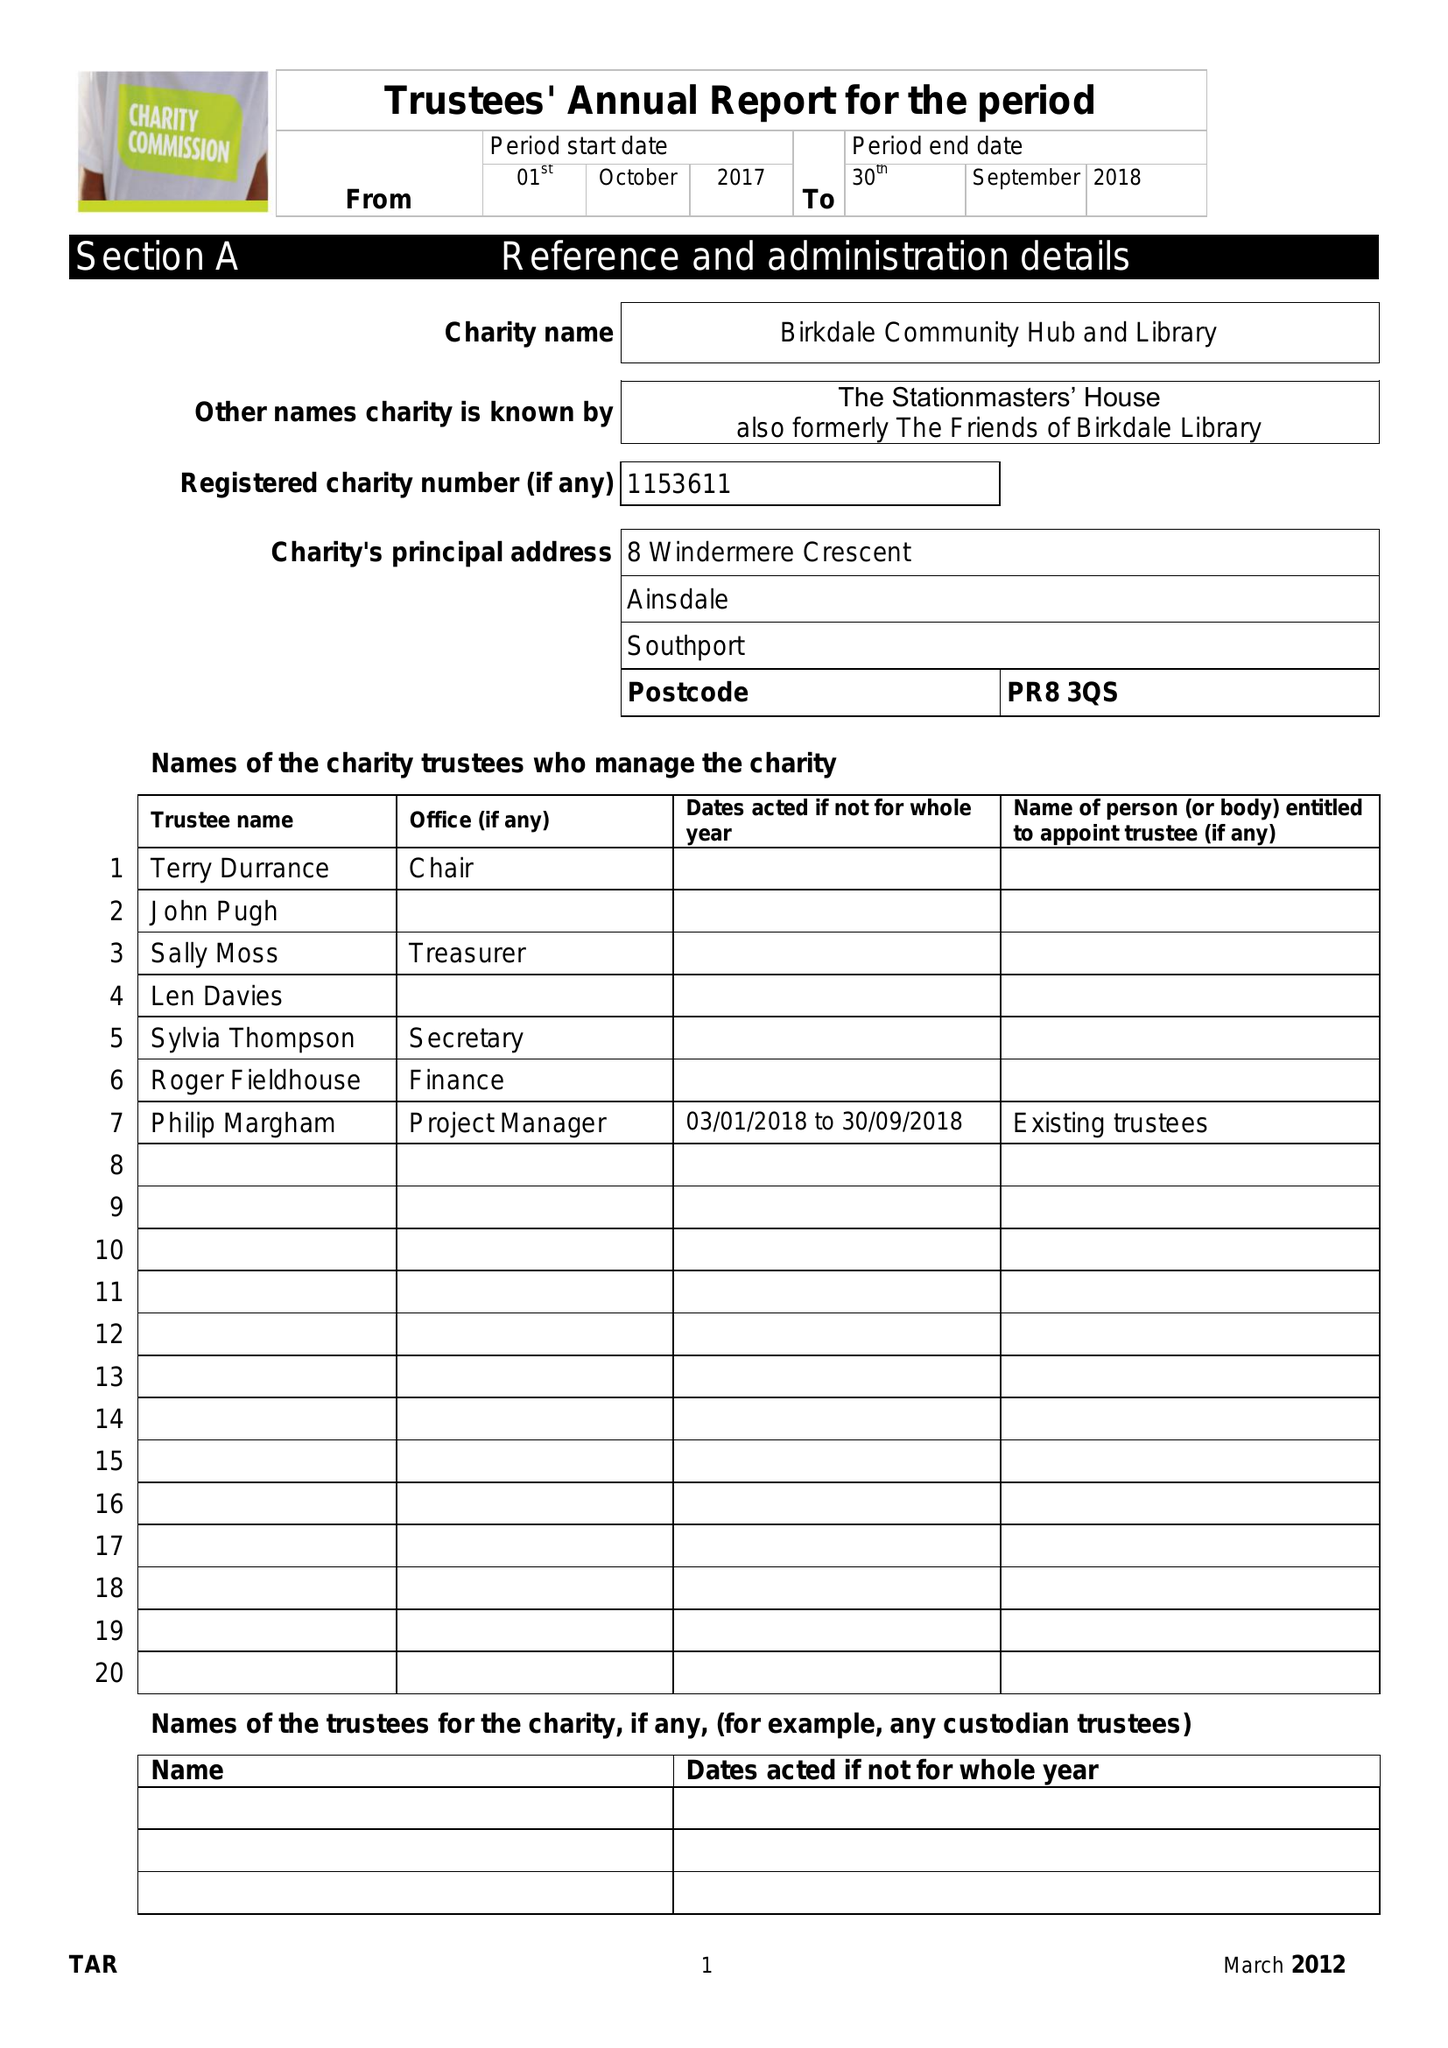What is the value for the charity_number?
Answer the question using a single word or phrase. 1153611 